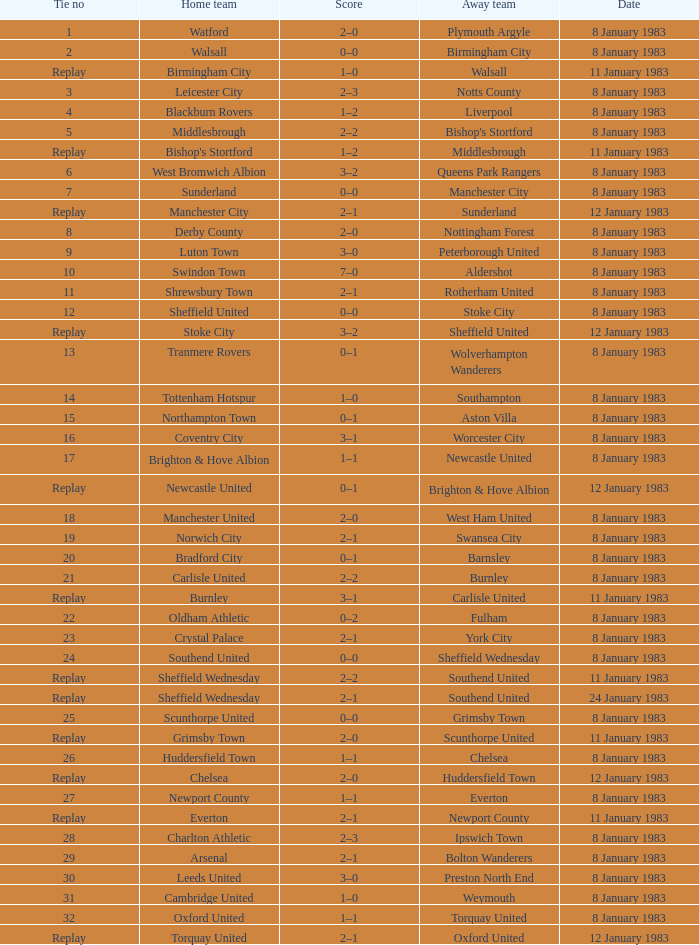On what date was Tie #26 played? 8 January 1983. 